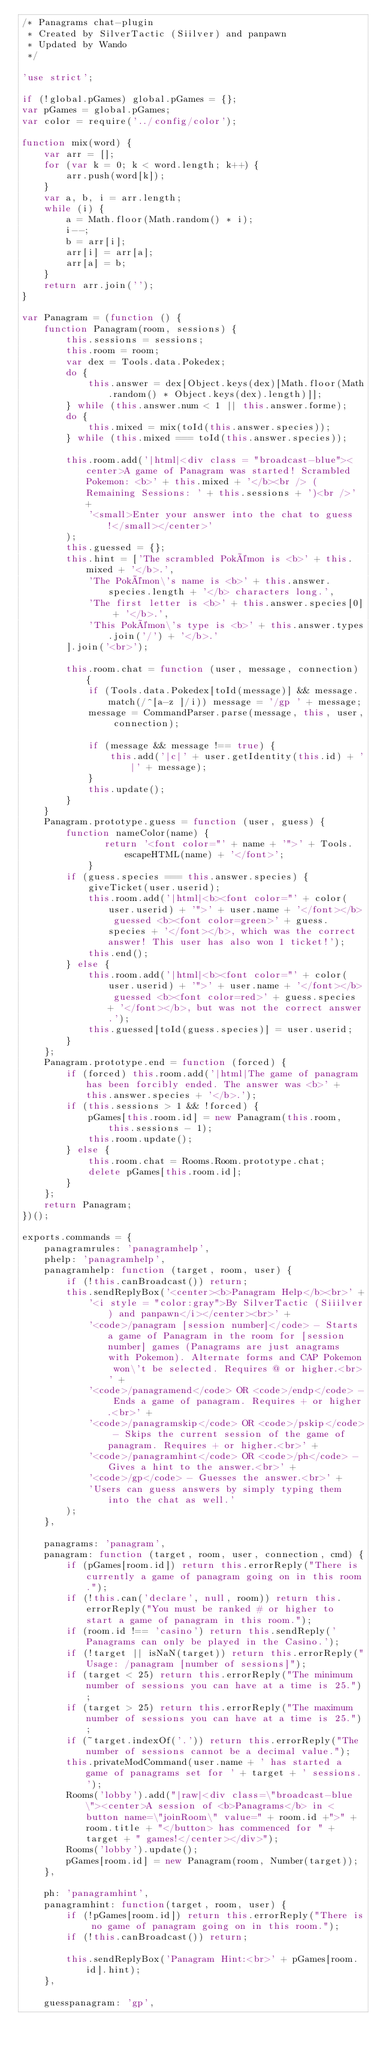<code> <loc_0><loc_0><loc_500><loc_500><_JavaScript_>/* Panagrams chat-plugin
 * Created by SilverTactic (Siilver) and panpawn
 * Updated by Wando
 */

'use strict';

if (!global.pGames) global.pGames = {};
var pGames = global.pGames;
var color = require('../config/color');

function mix(word) {
	var arr = [];
	for (var k = 0; k < word.length; k++) {
		arr.push(word[k]);
	}
	var a, b, i = arr.length;
	while (i) {
		a = Math.floor(Math.random() * i);
		i--;
		b = arr[i];
		arr[i] = arr[a];
		arr[a] = b;
	}
	return arr.join('');
}

var Panagram = (function () {
	function Panagram(room, sessions) {
		this.sessions = sessions;
		this.room = room;
		var dex = Tools.data.Pokedex;
		do {
			this.answer = dex[Object.keys(dex)[Math.floor(Math.random() * Object.keys(dex).length)]];
		} while (this.answer.num < 1 || this.answer.forme);
		do {
			this.mixed = mix(toId(this.answer.species));
		} while (this.mixed === toId(this.answer.species));

		this.room.add('|html|<div class = "broadcast-blue"><center>A game of Panagram was started! Scrambled Pokemon: <b>' + this.mixed + '</b><br /> (Remaining Sessions: ' + this.sessions + ')<br />' +
			'<small>Enter your answer into the chat to guess!</small></center>'
		);
		this.guessed = {};
		this.hint = ['The scrambled Pokémon is <b>' + this.mixed + '</b>.',
			'The Pokémon\'s name is <b>' + this.answer.species.length + '</b> characters long.',
			'The first letter is <b>' + this.answer.species[0] + '</b>.',
			'This Pokémon\'s type is <b>' + this.answer.types.join('/') + '</b>.'
		].join('<br>');

		this.room.chat = function (user, message, connection) {
			if (Tools.data.Pokedex[toId(message)] && message.match(/^[a-z ]/i)) message = '/gp ' + message;
			message = CommandParser.parse(message, this, user, connection);

			if (message && message !== true) {
				this.add('|c|' + user.getIdentity(this.id) + '|' + message);
			}
			this.update();
		}
	}
	Panagram.prototype.guess = function (user, guess) {
	    function nameColor(name) {
	           return '<font color="' + name + '">' + Tools.escapeHTML(name) + '</font>';
	        }
		if (guess.species === this.answer.species) {
			giveTicket(user.userid);
			this.room.add('|html|<b><font color="' + color(user.userid) + '">' + user.name + '</font></b> guessed <b><font color=green>' + guess.species + '</font></b>, which was the correct answer! This user has also won 1 ticket!');
			this.end();
		} else {
			this.room.add('|html|<b><font color="' + color(user.userid) + '">' + user.name + '</font></b> guessed <b><font color=red>' + guess.species + '</font></b>, but was not the correct answer.');
			this.guessed[toId(guess.species)] = user.userid;
		}
	};
	Panagram.prototype.end = function (forced) {
		if (forced) this.room.add('|html|The game of panagram has been forcibly ended. The answer was <b>' + this.answer.species + '</b>.');
		if (this.sessions > 1 && !forced) {
			pGames[this.room.id] = new Panagram(this.room, this.sessions - 1);
			this.room.update();
		} else {
			this.room.chat = Rooms.Room.prototype.chat;
			delete pGames[this.room.id];
		}
	};
	return Panagram;
})();

exports.commands = {
	panagramrules: 'panagramhelp',
	phelp: 'panagramhelp',
	panagramhelp: function (target, room, user) {
		if (!this.canBroadcast()) return;
		this.sendReplyBox('<center><b>Panagram Help</b><br>' +
			'<i style = "color:gray">By SilverTactic (Siiilver) and panpawn</i></center><br>' +
			'<code>/panagram [session number]</code> - Starts a game of Panagram in the room for [session number] games (Panagrams are just anagrams with Pokemon). Alternate forms and CAP Pokemon won\'t be selected. Requires @ or higher.<br>' +
			'<code>/panagramend</code> OR <code>/endp</code> - Ends a game of panagram. Requires + or higher.<br>' +
			'<code>/panagramskip</code> OR <code>/pskip</code> - Skips the current session of the game of panagram. Requires + or higher.<br>' +
			'<code>/panagramhint</code> OR <code>/ph</code> - Gives a hint to the answer.<br>' +
			'<code>/gp</code> - Guesses the answer.<br>' +
			'Users can guess answers by simply typing them into the chat as well.'
		);
	},

	panagrams: 'panagram',
	panagram: function (target, room, user, connection, cmd) {
		if (pGames[room.id]) return this.errorReply("There is currently a game of panagram going on in this room.");
		if (!this.can('declare', null, room)) return this.errorReply("You must be ranked # or higher to start a game of panagram in this room.");
		if (room.id !== 'casino') return this.sendReply('Panagrams can only be played in the Casino.');
		if (!target || isNaN(target)) return this.errorReply("Usage: /panagram [number of sessions]");
		if (target < 25) return this.errorReply("The minimum number of sessions you can have at a time is 25.");
		if (target > 25) return this.errorReply("The maximum number of sessions you can have at a time is 25.");
		if (~target.indexOf('.')) return this.errorReply("The number of sessions cannot be a decimal value.");
		this.privateModCommand(user.name + ' has started a game of panagrams set for ' + target + ' sessions.');
		Rooms('lobby').add("|raw|<div class=\"broadcast-blue\"><center>A session of <b>Panagrams</b> in <button name=\"joinRoom\" value=" + room.id +">" + room.title + "</button> has commenced for " + target + " games!</center></div>");
		Rooms('lobby').update();
		pGames[room.id] = new Panagram(room, Number(target));
	},

	ph: 'panagramhint',
	panagramhint: function(target, room, user) {
		if (!pGames[room.id]) return this.errorReply("There is no game of panagram going on in this room.");
		if (!this.canBroadcast()) return;

		this.sendReplyBox('Panagram Hint:<br>' + pGames[room.id].hint);
	},

	guesspanagram: 'gp',</code> 